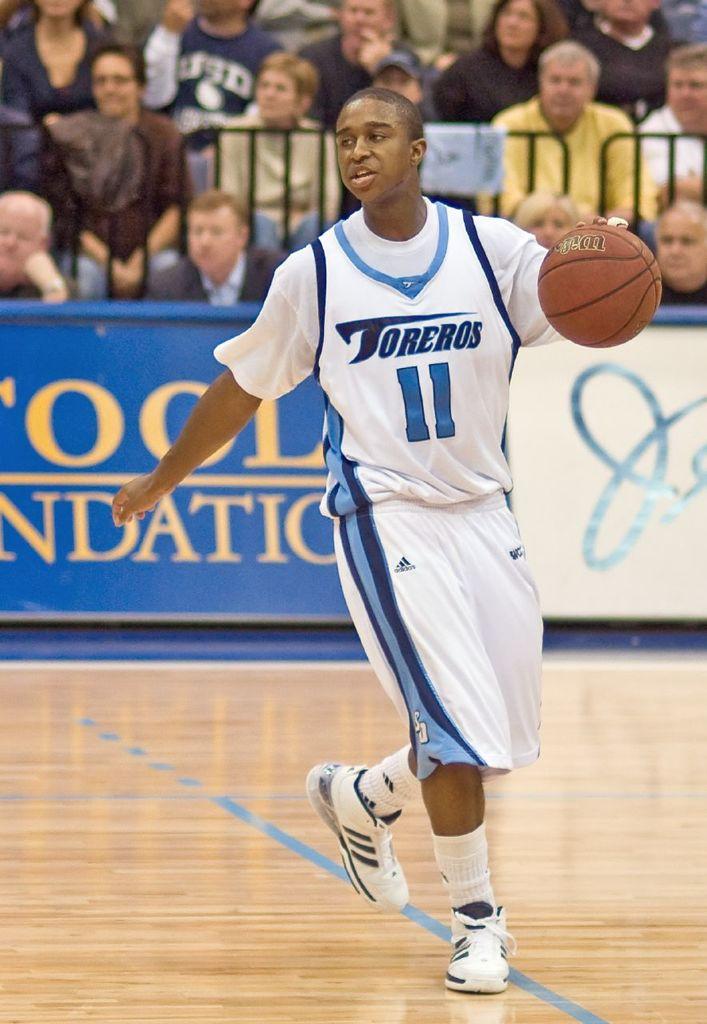What number is the player who is dribbling?
Provide a succinct answer. 11. What team does the player, play for?
Provide a succinct answer. Toreros. 